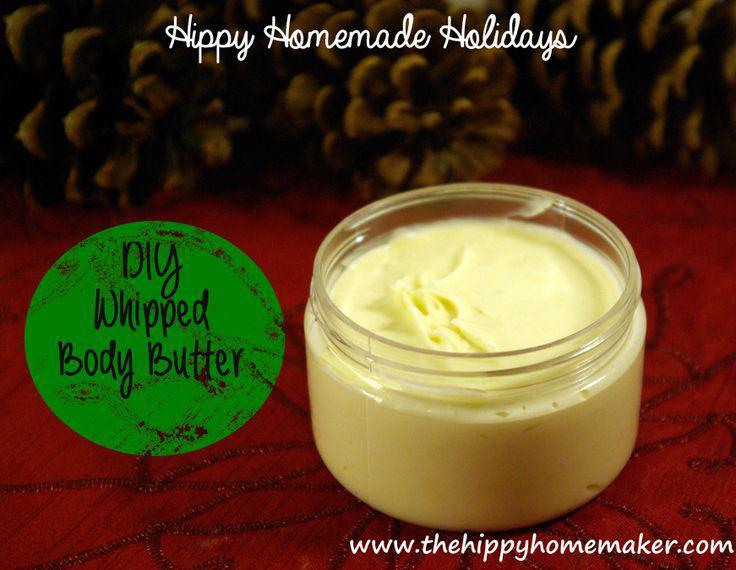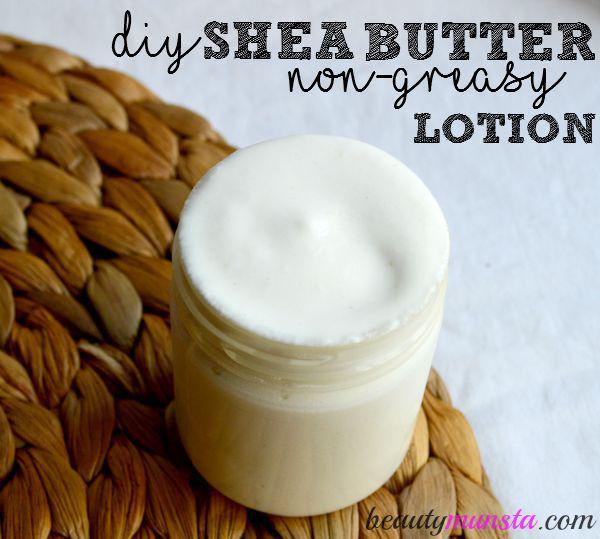The first image is the image on the left, the second image is the image on the right. Assess this claim about the two images: "There is a white lotion in one image and a yellow lotion in the other.". Correct or not? Answer yes or no. Yes. 